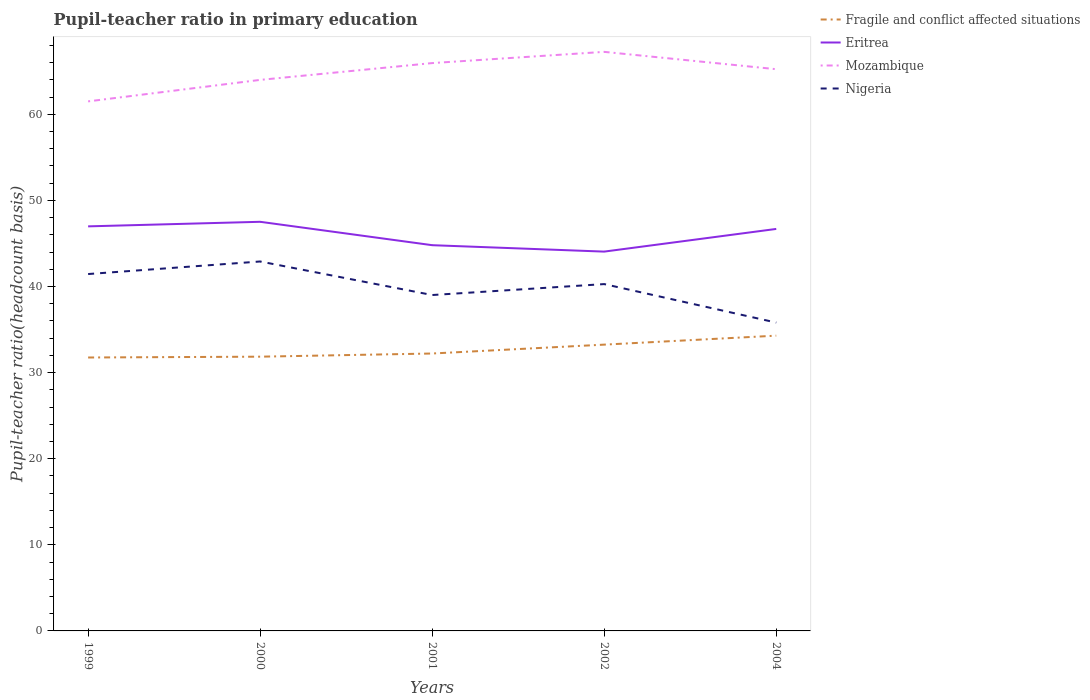Does the line corresponding to Mozambique intersect with the line corresponding to Nigeria?
Provide a succinct answer. No. Is the number of lines equal to the number of legend labels?
Keep it short and to the point. Yes. Across all years, what is the maximum pupil-teacher ratio in primary education in Fragile and conflict affected situations?
Offer a very short reply. 31.75. What is the total pupil-teacher ratio in primary education in Eritrea in the graph?
Offer a very short reply. 0.75. What is the difference between the highest and the second highest pupil-teacher ratio in primary education in Fragile and conflict affected situations?
Give a very brief answer. 2.54. How many lines are there?
Give a very brief answer. 4. How many years are there in the graph?
Provide a short and direct response. 5. Does the graph contain any zero values?
Provide a succinct answer. No. Where does the legend appear in the graph?
Provide a short and direct response. Top right. How are the legend labels stacked?
Make the answer very short. Vertical. What is the title of the graph?
Your answer should be compact. Pupil-teacher ratio in primary education. What is the label or title of the X-axis?
Your answer should be compact. Years. What is the label or title of the Y-axis?
Offer a very short reply. Pupil-teacher ratio(headcount basis). What is the Pupil-teacher ratio(headcount basis) of Fragile and conflict affected situations in 1999?
Offer a very short reply. 31.75. What is the Pupil-teacher ratio(headcount basis) of Eritrea in 1999?
Ensure brevity in your answer.  46.98. What is the Pupil-teacher ratio(headcount basis) of Mozambique in 1999?
Ensure brevity in your answer.  61.49. What is the Pupil-teacher ratio(headcount basis) in Nigeria in 1999?
Ensure brevity in your answer.  41.44. What is the Pupil-teacher ratio(headcount basis) in Fragile and conflict affected situations in 2000?
Give a very brief answer. 31.85. What is the Pupil-teacher ratio(headcount basis) of Eritrea in 2000?
Your answer should be compact. 47.51. What is the Pupil-teacher ratio(headcount basis) of Mozambique in 2000?
Ensure brevity in your answer.  63.99. What is the Pupil-teacher ratio(headcount basis) in Nigeria in 2000?
Keep it short and to the point. 42.9. What is the Pupil-teacher ratio(headcount basis) in Fragile and conflict affected situations in 2001?
Ensure brevity in your answer.  32.22. What is the Pupil-teacher ratio(headcount basis) of Eritrea in 2001?
Offer a terse response. 44.79. What is the Pupil-teacher ratio(headcount basis) of Mozambique in 2001?
Keep it short and to the point. 65.94. What is the Pupil-teacher ratio(headcount basis) of Nigeria in 2001?
Offer a very short reply. 39.01. What is the Pupil-teacher ratio(headcount basis) in Fragile and conflict affected situations in 2002?
Your answer should be very brief. 33.25. What is the Pupil-teacher ratio(headcount basis) of Eritrea in 2002?
Your answer should be compact. 44.05. What is the Pupil-teacher ratio(headcount basis) in Mozambique in 2002?
Give a very brief answer. 67.24. What is the Pupil-teacher ratio(headcount basis) in Nigeria in 2002?
Provide a short and direct response. 40.28. What is the Pupil-teacher ratio(headcount basis) in Fragile and conflict affected situations in 2004?
Ensure brevity in your answer.  34.29. What is the Pupil-teacher ratio(headcount basis) of Eritrea in 2004?
Give a very brief answer. 46.68. What is the Pupil-teacher ratio(headcount basis) of Mozambique in 2004?
Keep it short and to the point. 65.23. What is the Pupil-teacher ratio(headcount basis) of Nigeria in 2004?
Offer a terse response. 35.81. Across all years, what is the maximum Pupil-teacher ratio(headcount basis) of Fragile and conflict affected situations?
Provide a succinct answer. 34.29. Across all years, what is the maximum Pupil-teacher ratio(headcount basis) of Eritrea?
Your answer should be very brief. 47.51. Across all years, what is the maximum Pupil-teacher ratio(headcount basis) in Mozambique?
Your answer should be compact. 67.24. Across all years, what is the maximum Pupil-teacher ratio(headcount basis) in Nigeria?
Offer a very short reply. 42.9. Across all years, what is the minimum Pupil-teacher ratio(headcount basis) of Fragile and conflict affected situations?
Your answer should be very brief. 31.75. Across all years, what is the minimum Pupil-teacher ratio(headcount basis) in Eritrea?
Make the answer very short. 44.05. Across all years, what is the minimum Pupil-teacher ratio(headcount basis) in Mozambique?
Provide a short and direct response. 61.49. Across all years, what is the minimum Pupil-teacher ratio(headcount basis) of Nigeria?
Ensure brevity in your answer.  35.81. What is the total Pupil-teacher ratio(headcount basis) in Fragile and conflict affected situations in the graph?
Give a very brief answer. 163.35. What is the total Pupil-teacher ratio(headcount basis) of Eritrea in the graph?
Keep it short and to the point. 230.02. What is the total Pupil-teacher ratio(headcount basis) of Mozambique in the graph?
Provide a short and direct response. 323.9. What is the total Pupil-teacher ratio(headcount basis) in Nigeria in the graph?
Give a very brief answer. 199.43. What is the difference between the Pupil-teacher ratio(headcount basis) in Fragile and conflict affected situations in 1999 and that in 2000?
Provide a short and direct response. -0.1. What is the difference between the Pupil-teacher ratio(headcount basis) in Eritrea in 1999 and that in 2000?
Your response must be concise. -0.53. What is the difference between the Pupil-teacher ratio(headcount basis) of Mozambique in 1999 and that in 2000?
Give a very brief answer. -2.5. What is the difference between the Pupil-teacher ratio(headcount basis) of Nigeria in 1999 and that in 2000?
Give a very brief answer. -1.46. What is the difference between the Pupil-teacher ratio(headcount basis) of Fragile and conflict affected situations in 1999 and that in 2001?
Make the answer very short. -0.46. What is the difference between the Pupil-teacher ratio(headcount basis) of Eritrea in 1999 and that in 2001?
Offer a very short reply. 2.19. What is the difference between the Pupil-teacher ratio(headcount basis) in Mozambique in 1999 and that in 2001?
Offer a terse response. -4.45. What is the difference between the Pupil-teacher ratio(headcount basis) in Nigeria in 1999 and that in 2001?
Your response must be concise. 2.44. What is the difference between the Pupil-teacher ratio(headcount basis) of Fragile and conflict affected situations in 1999 and that in 2002?
Your answer should be compact. -1.49. What is the difference between the Pupil-teacher ratio(headcount basis) in Eritrea in 1999 and that in 2002?
Your answer should be compact. 2.93. What is the difference between the Pupil-teacher ratio(headcount basis) of Mozambique in 1999 and that in 2002?
Your response must be concise. -5.75. What is the difference between the Pupil-teacher ratio(headcount basis) of Nigeria in 1999 and that in 2002?
Offer a terse response. 1.17. What is the difference between the Pupil-teacher ratio(headcount basis) in Fragile and conflict affected situations in 1999 and that in 2004?
Provide a succinct answer. -2.54. What is the difference between the Pupil-teacher ratio(headcount basis) of Eritrea in 1999 and that in 2004?
Provide a short and direct response. 0.3. What is the difference between the Pupil-teacher ratio(headcount basis) in Mozambique in 1999 and that in 2004?
Your response must be concise. -3.74. What is the difference between the Pupil-teacher ratio(headcount basis) of Nigeria in 1999 and that in 2004?
Your response must be concise. 5.64. What is the difference between the Pupil-teacher ratio(headcount basis) in Fragile and conflict affected situations in 2000 and that in 2001?
Provide a succinct answer. -0.37. What is the difference between the Pupil-teacher ratio(headcount basis) in Eritrea in 2000 and that in 2001?
Give a very brief answer. 2.72. What is the difference between the Pupil-teacher ratio(headcount basis) of Mozambique in 2000 and that in 2001?
Your response must be concise. -1.95. What is the difference between the Pupil-teacher ratio(headcount basis) in Nigeria in 2000 and that in 2001?
Your answer should be very brief. 3.9. What is the difference between the Pupil-teacher ratio(headcount basis) in Fragile and conflict affected situations in 2000 and that in 2002?
Make the answer very short. -1.4. What is the difference between the Pupil-teacher ratio(headcount basis) of Eritrea in 2000 and that in 2002?
Ensure brevity in your answer.  3.46. What is the difference between the Pupil-teacher ratio(headcount basis) in Mozambique in 2000 and that in 2002?
Provide a short and direct response. -3.26. What is the difference between the Pupil-teacher ratio(headcount basis) of Nigeria in 2000 and that in 2002?
Make the answer very short. 2.62. What is the difference between the Pupil-teacher ratio(headcount basis) in Fragile and conflict affected situations in 2000 and that in 2004?
Your response must be concise. -2.44. What is the difference between the Pupil-teacher ratio(headcount basis) in Eritrea in 2000 and that in 2004?
Your response must be concise. 0.83. What is the difference between the Pupil-teacher ratio(headcount basis) of Mozambique in 2000 and that in 2004?
Give a very brief answer. -1.24. What is the difference between the Pupil-teacher ratio(headcount basis) in Nigeria in 2000 and that in 2004?
Provide a short and direct response. 7.09. What is the difference between the Pupil-teacher ratio(headcount basis) of Fragile and conflict affected situations in 2001 and that in 2002?
Provide a succinct answer. -1.03. What is the difference between the Pupil-teacher ratio(headcount basis) of Eritrea in 2001 and that in 2002?
Make the answer very short. 0.75. What is the difference between the Pupil-teacher ratio(headcount basis) of Mozambique in 2001 and that in 2002?
Your response must be concise. -1.3. What is the difference between the Pupil-teacher ratio(headcount basis) of Nigeria in 2001 and that in 2002?
Make the answer very short. -1.27. What is the difference between the Pupil-teacher ratio(headcount basis) of Fragile and conflict affected situations in 2001 and that in 2004?
Provide a succinct answer. -2.07. What is the difference between the Pupil-teacher ratio(headcount basis) in Eritrea in 2001 and that in 2004?
Give a very brief answer. -1.89. What is the difference between the Pupil-teacher ratio(headcount basis) of Mozambique in 2001 and that in 2004?
Ensure brevity in your answer.  0.71. What is the difference between the Pupil-teacher ratio(headcount basis) of Nigeria in 2001 and that in 2004?
Give a very brief answer. 3.2. What is the difference between the Pupil-teacher ratio(headcount basis) in Fragile and conflict affected situations in 2002 and that in 2004?
Ensure brevity in your answer.  -1.04. What is the difference between the Pupil-teacher ratio(headcount basis) of Eritrea in 2002 and that in 2004?
Your response must be concise. -2.63. What is the difference between the Pupil-teacher ratio(headcount basis) in Mozambique in 2002 and that in 2004?
Your answer should be very brief. 2.01. What is the difference between the Pupil-teacher ratio(headcount basis) in Nigeria in 2002 and that in 2004?
Your answer should be very brief. 4.47. What is the difference between the Pupil-teacher ratio(headcount basis) of Fragile and conflict affected situations in 1999 and the Pupil-teacher ratio(headcount basis) of Eritrea in 2000?
Provide a succinct answer. -15.76. What is the difference between the Pupil-teacher ratio(headcount basis) in Fragile and conflict affected situations in 1999 and the Pupil-teacher ratio(headcount basis) in Mozambique in 2000?
Keep it short and to the point. -32.24. What is the difference between the Pupil-teacher ratio(headcount basis) in Fragile and conflict affected situations in 1999 and the Pupil-teacher ratio(headcount basis) in Nigeria in 2000?
Offer a very short reply. -11.15. What is the difference between the Pupil-teacher ratio(headcount basis) in Eritrea in 1999 and the Pupil-teacher ratio(headcount basis) in Mozambique in 2000?
Make the answer very short. -17.01. What is the difference between the Pupil-teacher ratio(headcount basis) of Eritrea in 1999 and the Pupil-teacher ratio(headcount basis) of Nigeria in 2000?
Ensure brevity in your answer.  4.08. What is the difference between the Pupil-teacher ratio(headcount basis) in Mozambique in 1999 and the Pupil-teacher ratio(headcount basis) in Nigeria in 2000?
Ensure brevity in your answer.  18.59. What is the difference between the Pupil-teacher ratio(headcount basis) of Fragile and conflict affected situations in 1999 and the Pupil-teacher ratio(headcount basis) of Eritrea in 2001?
Provide a short and direct response. -13.04. What is the difference between the Pupil-teacher ratio(headcount basis) of Fragile and conflict affected situations in 1999 and the Pupil-teacher ratio(headcount basis) of Mozambique in 2001?
Your answer should be very brief. -34.19. What is the difference between the Pupil-teacher ratio(headcount basis) in Fragile and conflict affected situations in 1999 and the Pupil-teacher ratio(headcount basis) in Nigeria in 2001?
Provide a short and direct response. -7.25. What is the difference between the Pupil-teacher ratio(headcount basis) of Eritrea in 1999 and the Pupil-teacher ratio(headcount basis) of Mozambique in 2001?
Provide a succinct answer. -18.96. What is the difference between the Pupil-teacher ratio(headcount basis) in Eritrea in 1999 and the Pupil-teacher ratio(headcount basis) in Nigeria in 2001?
Offer a very short reply. 7.97. What is the difference between the Pupil-teacher ratio(headcount basis) in Mozambique in 1999 and the Pupil-teacher ratio(headcount basis) in Nigeria in 2001?
Offer a terse response. 22.49. What is the difference between the Pupil-teacher ratio(headcount basis) of Fragile and conflict affected situations in 1999 and the Pupil-teacher ratio(headcount basis) of Eritrea in 2002?
Provide a short and direct response. -12.3. What is the difference between the Pupil-teacher ratio(headcount basis) in Fragile and conflict affected situations in 1999 and the Pupil-teacher ratio(headcount basis) in Mozambique in 2002?
Your response must be concise. -35.49. What is the difference between the Pupil-teacher ratio(headcount basis) of Fragile and conflict affected situations in 1999 and the Pupil-teacher ratio(headcount basis) of Nigeria in 2002?
Offer a very short reply. -8.52. What is the difference between the Pupil-teacher ratio(headcount basis) of Eritrea in 1999 and the Pupil-teacher ratio(headcount basis) of Mozambique in 2002?
Provide a succinct answer. -20.26. What is the difference between the Pupil-teacher ratio(headcount basis) of Eritrea in 1999 and the Pupil-teacher ratio(headcount basis) of Nigeria in 2002?
Ensure brevity in your answer.  6.7. What is the difference between the Pupil-teacher ratio(headcount basis) in Mozambique in 1999 and the Pupil-teacher ratio(headcount basis) in Nigeria in 2002?
Offer a very short reply. 21.22. What is the difference between the Pupil-teacher ratio(headcount basis) of Fragile and conflict affected situations in 1999 and the Pupil-teacher ratio(headcount basis) of Eritrea in 2004?
Offer a very short reply. -14.93. What is the difference between the Pupil-teacher ratio(headcount basis) of Fragile and conflict affected situations in 1999 and the Pupil-teacher ratio(headcount basis) of Mozambique in 2004?
Your answer should be very brief. -33.48. What is the difference between the Pupil-teacher ratio(headcount basis) in Fragile and conflict affected situations in 1999 and the Pupil-teacher ratio(headcount basis) in Nigeria in 2004?
Ensure brevity in your answer.  -4.05. What is the difference between the Pupil-teacher ratio(headcount basis) in Eritrea in 1999 and the Pupil-teacher ratio(headcount basis) in Mozambique in 2004?
Your answer should be very brief. -18.25. What is the difference between the Pupil-teacher ratio(headcount basis) in Eritrea in 1999 and the Pupil-teacher ratio(headcount basis) in Nigeria in 2004?
Make the answer very short. 11.17. What is the difference between the Pupil-teacher ratio(headcount basis) of Mozambique in 1999 and the Pupil-teacher ratio(headcount basis) of Nigeria in 2004?
Provide a short and direct response. 25.69. What is the difference between the Pupil-teacher ratio(headcount basis) in Fragile and conflict affected situations in 2000 and the Pupil-teacher ratio(headcount basis) in Eritrea in 2001?
Provide a succinct answer. -12.95. What is the difference between the Pupil-teacher ratio(headcount basis) of Fragile and conflict affected situations in 2000 and the Pupil-teacher ratio(headcount basis) of Mozambique in 2001?
Give a very brief answer. -34.09. What is the difference between the Pupil-teacher ratio(headcount basis) of Fragile and conflict affected situations in 2000 and the Pupil-teacher ratio(headcount basis) of Nigeria in 2001?
Ensure brevity in your answer.  -7.16. What is the difference between the Pupil-teacher ratio(headcount basis) of Eritrea in 2000 and the Pupil-teacher ratio(headcount basis) of Mozambique in 2001?
Provide a succinct answer. -18.43. What is the difference between the Pupil-teacher ratio(headcount basis) of Eritrea in 2000 and the Pupil-teacher ratio(headcount basis) of Nigeria in 2001?
Give a very brief answer. 8.5. What is the difference between the Pupil-teacher ratio(headcount basis) of Mozambique in 2000 and the Pupil-teacher ratio(headcount basis) of Nigeria in 2001?
Ensure brevity in your answer.  24.98. What is the difference between the Pupil-teacher ratio(headcount basis) of Fragile and conflict affected situations in 2000 and the Pupil-teacher ratio(headcount basis) of Eritrea in 2002?
Ensure brevity in your answer.  -12.2. What is the difference between the Pupil-teacher ratio(headcount basis) in Fragile and conflict affected situations in 2000 and the Pupil-teacher ratio(headcount basis) in Mozambique in 2002?
Give a very brief answer. -35.4. What is the difference between the Pupil-teacher ratio(headcount basis) in Fragile and conflict affected situations in 2000 and the Pupil-teacher ratio(headcount basis) in Nigeria in 2002?
Your answer should be very brief. -8.43. What is the difference between the Pupil-teacher ratio(headcount basis) of Eritrea in 2000 and the Pupil-teacher ratio(headcount basis) of Mozambique in 2002?
Offer a very short reply. -19.73. What is the difference between the Pupil-teacher ratio(headcount basis) in Eritrea in 2000 and the Pupil-teacher ratio(headcount basis) in Nigeria in 2002?
Your answer should be very brief. 7.23. What is the difference between the Pupil-teacher ratio(headcount basis) of Mozambique in 2000 and the Pupil-teacher ratio(headcount basis) of Nigeria in 2002?
Provide a short and direct response. 23.71. What is the difference between the Pupil-teacher ratio(headcount basis) of Fragile and conflict affected situations in 2000 and the Pupil-teacher ratio(headcount basis) of Eritrea in 2004?
Your answer should be very brief. -14.83. What is the difference between the Pupil-teacher ratio(headcount basis) in Fragile and conflict affected situations in 2000 and the Pupil-teacher ratio(headcount basis) in Mozambique in 2004?
Ensure brevity in your answer.  -33.38. What is the difference between the Pupil-teacher ratio(headcount basis) of Fragile and conflict affected situations in 2000 and the Pupil-teacher ratio(headcount basis) of Nigeria in 2004?
Your answer should be very brief. -3.96. What is the difference between the Pupil-teacher ratio(headcount basis) in Eritrea in 2000 and the Pupil-teacher ratio(headcount basis) in Mozambique in 2004?
Give a very brief answer. -17.72. What is the difference between the Pupil-teacher ratio(headcount basis) in Eritrea in 2000 and the Pupil-teacher ratio(headcount basis) in Nigeria in 2004?
Make the answer very short. 11.7. What is the difference between the Pupil-teacher ratio(headcount basis) in Mozambique in 2000 and the Pupil-teacher ratio(headcount basis) in Nigeria in 2004?
Give a very brief answer. 28.18. What is the difference between the Pupil-teacher ratio(headcount basis) in Fragile and conflict affected situations in 2001 and the Pupil-teacher ratio(headcount basis) in Eritrea in 2002?
Give a very brief answer. -11.83. What is the difference between the Pupil-teacher ratio(headcount basis) in Fragile and conflict affected situations in 2001 and the Pupil-teacher ratio(headcount basis) in Mozambique in 2002?
Make the answer very short. -35.03. What is the difference between the Pupil-teacher ratio(headcount basis) in Fragile and conflict affected situations in 2001 and the Pupil-teacher ratio(headcount basis) in Nigeria in 2002?
Offer a very short reply. -8.06. What is the difference between the Pupil-teacher ratio(headcount basis) of Eritrea in 2001 and the Pupil-teacher ratio(headcount basis) of Mozambique in 2002?
Provide a succinct answer. -22.45. What is the difference between the Pupil-teacher ratio(headcount basis) in Eritrea in 2001 and the Pupil-teacher ratio(headcount basis) in Nigeria in 2002?
Offer a terse response. 4.52. What is the difference between the Pupil-teacher ratio(headcount basis) in Mozambique in 2001 and the Pupil-teacher ratio(headcount basis) in Nigeria in 2002?
Provide a short and direct response. 25.66. What is the difference between the Pupil-teacher ratio(headcount basis) of Fragile and conflict affected situations in 2001 and the Pupil-teacher ratio(headcount basis) of Eritrea in 2004?
Keep it short and to the point. -14.47. What is the difference between the Pupil-teacher ratio(headcount basis) in Fragile and conflict affected situations in 2001 and the Pupil-teacher ratio(headcount basis) in Mozambique in 2004?
Give a very brief answer. -33.02. What is the difference between the Pupil-teacher ratio(headcount basis) of Fragile and conflict affected situations in 2001 and the Pupil-teacher ratio(headcount basis) of Nigeria in 2004?
Your answer should be very brief. -3.59. What is the difference between the Pupil-teacher ratio(headcount basis) in Eritrea in 2001 and the Pupil-teacher ratio(headcount basis) in Mozambique in 2004?
Offer a terse response. -20.44. What is the difference between the Pupil-teacher ratio(headcount basis) of Eritrea in 2001 and the Pupil-teacher ratio(headcount basis) of Nigeria in 2004?
Your answer should be very brief. 8.99. What is the difference between the Pupil-teacher ratio(headcount basis) of Mozambique in 2001 and the Pupil-teacher ratio(headcount basis) of Nigeria in 2004?
Give a very brief answer. 30.13. What is the difference between the Pupil-teacher ratio(headcount basis) of Fragile and conflict affected situations in 2002 and the Pupil-teacher ratio(headcount basis) of Eritrea in 2004?
Your response must be concise. -13.44. What is the difference between the Pupil-teacher ratio(headcount basis) of Fragile and conflict affected situations in 2002 and the Pupil-teacher ratio(headcount basis) of Mozambique in 2004?
Your answer should be compact. -31.98. What is the difference between the Pupil-teacher ratio(headcount basis) of Fragile and conflict affected situations in 2002 and the Pupil-teacher ratio(headcount basis) of Nigeria in 2004?
Make the answer very short. -2.56. What is the difference between the Pupil-teacher ratio(headcount basis) in Eritrea in 2002 and the Pupil-teacher ratio(headcount basis) in Mozambique in 2004?
Offer a terse response. -21.18. What is the difference between the Pupil-teacher ratio(headcount basis) in Eritrea in 2002 and the Pupil-teacher ratio(headcount basis) in Nigeria in 2004?
Offer a terse response. 8.24. What is the difference between the Pupil-teacher ratio(headcount basis) of Mozambique in 2002 and the Pupil-teacher ratio(headcount basis) of Nigeria in 2004?
Keep it short and to the point. 31.44. What is the average Pupil-teacher ratio(headcount basis) of Fragile and conflict affected situations per year?
Keep it short and to the point. 32.67. What is the average Pupil-teacher ratio(headcount basis) in Eritrea per year?
Offer a very short reply. 46. What is the average Pupil-teacher ratio(headcount basis) of Mozambique per year?
Provide a short and direct response. 64.78. What is the average Pupil-teacher ratio(headcount basis) of Nigeria per year?
Provide a short and direct response. 39.89. In the year 1999, what is the difference between the Pupil-teacher ratio(headcount basis) of Fragile and conflict affected situations and Pupil-teacher ratio(headcount basis) of Eritrea?
Offer a very short reply. -15.23. In the year 1999, what is the difference between the Pupil-teacher ratio(headcount basis) of Fragile and conflict affected situations and Pupil-teacher ratio(headcount basis) of Mozambique?
Your response must be concise. -29.74. In the year 1999, what is the difference between the Pupil-teacher ratio(headcount basis) of Fragile and conflict affected situations and Pupil-teacher ratio(headcount basis) of Nigeria?
Your answer should be compact. -9.69. In the year 1999, what is the difference between the Pupil-teacher ratio(headcount basis) in Eritrea and Pupil-teacher ratio(headcount basis) in Mozambique?
Provide a short and direct response. -14.51. In the year 1999, what is the difference between the Pupil-teacher ratio(headcount basis) of Eritrea and Pupil-teacher ratio(headcount basis) of Nigeria?
Offer a terse response. 5.54. In the year 1999, what is the difference between the Pupil-teacher ratio(headcount basis) in Mozambique and Pupil-teacher ratio(headcount basis) in Nigeria?
Your answer should be compact. 20.05. In the year 2000, what is the difference between the Pupil-teacher ratio(headcount basis) of Fragile and conflict affected situations and Pupil-teacher ratio(headcount basis) of Eritrea?
Provide a succinct answer. -15.66. In the year 2000, what is the difference between the Pupil-teacher ratio(headcount basis) of Fragile and conflict affected situations and Pupil-teacher ratio(headcount basis) of Mozambique?
Keep it short and to the point. -32.14. In the year 2000, what is the difference between the Pupil-teacher ratio(headcount basis) of Fragile and conflict affected situations and Pupil-teacher ratio(headcount basis) of Nigeria?
Provide a short and direct response. -11.05. In the year 2000, what is the difference between the Pupil-teacher ratio(headcount basis) of Eritrea and Pupil-teacher ratio(headcount basis) of Mozambique?
Offer a terse response. -16.48. In the year 2000, what is the difference between the Pupil-teacher ratio(headcount basis) of Eritrea and Pupil-teacher ratio(headcount basis) of Nigeria?
Provide a short and direct response. 4.61. In the year 2000, what is the difference between the Pupil-teacher ratio(headcount basis) of Mozambique and Pupil-teacher ratio(headcount basis) of Nigeria?
Provide a short and direct response. 21.09. In the year 2001, what is the difference between the Pupil-teacher ratio(headcount basis) in Fragile and conflict affected situations and Pupil-teacher ratio(headcount basis) in Eritrea?
Offer a very short reply. -12.58. In the year 2001, what is the difference between the Pupil-teacher ratio(headcount basis) of Fragile and conflict affected situations and Pupil-teacher ratio(headcount basis) of Mozambique?
Offer a very short reply. -33.73. In the year 2001, what is the difference between the Pupil-teacher ratio(headcount basis) in Fragile and conflict affected situations and Pupil-teacher ratio(headcount basis) in Nigeria?
Ensure brevity in your answer.  -6.79. In the year 2001, what is the difference between the Pupil-teacher ratio(headcount basis) of Eritrea and Pupil-teacher ratio(headcount basis) of Mozambique?
Offer a terse response. -21.15. In the year 2001, what is the difference between the Pupil-teacher ratio(headcount basis) of Eritrea and Pupil-teacher ratio(headcount basis) of Nigeria?
Your answer should be compact. 5.79. In the year 2001, what is the difference between the Pupil-teacher ratio(headcount basis) in Mozambique and Pupil-teacher ratio(headcount basis) in Nigeria?
Your answer should be very brief. 26.94. In the year 2002, what is the difference between the Pupil-teacher ratio(headcount basis) of Fragile and conflict affected situations and Pupil-teacher ratio(headcount basis) of Eritrea?
Your answer should be very brief. -10.8. In the year 2002, what is the difference between the Pupil-teacher ratio(headcount basis) of Fragile and conflict affected situations and Pupil-teacher ratio(headcount basis) of Mozambique?
Your answer should be compact. -34. In the year 2002, what is the difference between the Pupil-teacher ratio(headcount basis) of Fragile and conflict affected situations and Pupil-teacher ratio(headcount basis) of Nigeria?
Provide a succinct answer. -7.03. In the year 2002, what is the difference between the Pupil-teacher ratio(headcount basis) in Eritrea and Pupil-teacher ratio(headcount basis) in Mozambique?
Give a very brief answer. -23.2. In the year 2002, what is the difference between the Pupil-teacher ratio(headcount basis) in Eritrea and Pupil-teacher ratio(headcount basis) in Nigeria?
Make the answer very short. 3.77. In the year 2002, what is the difference between the Pupil-teacher ratio(headcount basis) of Mozambique and Pupil-teacher ratio(headcount basis) of Nigeria?
Offer a terse response. 26.97. In the year 2004, what is the difference between the Pupil-teacher ratio(headcount basis) in Fragile and conflict affected situations and Pupil-teacher ratio(headcount basis) in Eritrea?
Offer a terse response. -12.39. In the year 2004, what is the difference between the Pupil-teacher ratio(headcount basis) of Fragile and conflict affected situations and Pupil-teacher ratio(headcount basis) of Mozambique?
Your response must be concise. -30.94. In the year 2004, what is the difference between the Pupil-teacher ratio(headcount basis) of Fragile and conflict affected situations and Pupil-teacher ratio(headcount basis) of Nigeria?
Give a very brief answer. -1.52. In the year 2004, what is the difference between the Pupil-teacher ratio(headcount basis) in Eritrea and Pupil-teacher ratio(headcount basis) in Mozambique?
Make the answer very short. -18.55. In the year 2004, what is the difference between the Pupil-teacher ratio(headcount basis) in Eritrea and Pupil-teacher ratio(headcount basis) in Nigeria?
Your answer should be compact. 10.88. In the year 2004, what is the difference between the Pupil-teacher ratio(headcount basis) in Mozambique and Pupil-teacher ratio(headcount basis) in Nigeria?
Your answer should be compact. 29.42. What is the ratio of the Pupil-teacher ratio(headcount basis) in Fragile and conflict affected situations in 1999 to that in 2000?
Provide a succinct answer. 1. What is the ratio of the Pupil-teacher ratio(headcount basis) in Eritrea in 1999 to that in 2000?
Your answer should be very brief. 0.99. What is the ratio of the Pupil-teacher ratio(headcount basis) of Mozambique in 1999 to that in 2000?
Offer a very short reply. 0.96. What is the ratio of the Pupil-teacher ratio(headcount basis) in Nigeria in 1999 to that in 2000?
Give a very brief answer. 0.97. What is the ratio of the Pupil-teacher ratio(headcount basis) of Fragile and conflict affected situations in 1999 to that in 2001?
Offer a very short reply. 0.99. What is the ratio of the Pupil-teacher ratio(headcount basis) in Eritrea in 1999 to that in 2001?
Offer a terse response. 1.05. What is the ratio of the Pupil-teacher ratio(headcount basis) in Mozambique in 1999 to that in 2001?
Provide a succinct answer. 0.93. What is the ratio of the Pupil-teacher ratio(headcount basis) in Nigeria in 1999 to that in 2001?
Offer a terse response. 1.06. What is the ratio of the Pupil-teacher ratio(headcount basis) of Fragile and conflict affected situations in 1999 to that in 2002?
Your response must be concise. 0.96. What is the ratio of the Pupil-teacher ratio(headcount basis) in Eritrea in 1999 to that in 2002?
Offer a very short reply. 1.07. What is the ratio of the Pupil-teacher ratio(headcount basis) in Mozambique in 1999 to that in 2002?
Your answer should be very brief. 0.91. What is the ratio of the Pupil-teacher ratio(headcount basis) in Nigeria in 1999 to that in 2002?
Your answer should be compact. 1.03. What is the ratio of the Pupil-teacher ratio(headcount basis) of Fragile and conflict affected situations in 1999 to that in 2004?
Your answer should be compact. 0.93. What is the ratio of the Pupil-teacher ratio(headcount basis) of Eritrea in 1999 to that in 2004?
Offer a very short reply. 1.01. What is the ratio of the Pupil-teacher ratio(headcount basis) in Mozambique in 1999 to that in 2004?
Provide a succinct answer. 0.94. What is the ratio of the Pupil-teacher ratio(headcount basis) of Nigeria in 1999 to that in 2004?
Make the answer very short. 1.16. What is the ratio of the Pupil-teacher ratio(headcount basis) of Eritrea in 2000 to that in 2001?
Your answer should be very brief. 1.06. What is the ratio of the Pupil-teacher ratio(headcount basis) in Mozambique in 2000 to that in 2001?
Ensure brevity in your answer.  0.97. What is the ratio of the Pupil-teacher ratio(headcount basis) in Nigeria in 2000 to that in 2001?
Offer a very short reply. 1.1. What is the ratio of the Pupil-teacher ratio(headcount basis) of Fragile and conflict affected situations in 2000 to that in 2002?
Make the answer very short. 0.96. What is the ratio of the Pupil-teacher ratio(headcount basis) of Eritrea in 2000 to that in 2002?
Give a very brief answer. 1.08. What is the ratio of the Pupil-teacher ratio(headcount basis) in Mozambique in 2000 to that in 2002?
Your response must be concise. 0.95. What is the ratio of the Pupil-teacher ratio(headcount basis) of Nigeria in 2000 to that in 2002?
Offer a terse response. 1.07. What is the ratio of the Pupil-teacher ratio(headcount basis) in Fragile and conflict affected situations in 2000 to that in 2004?
Give a very brief answer. 0.93. What is the ratio of the Pupil-teacher ratio(headcount basis) in Eritrea in 2000 to that in 2004?
Offer a very short reply. 1.02. What is the ratio of the Pupil-teacher ratio(headcount basis) in Nigeria in 2000 to that in 2004?
Make the answer very short. 1.2. What is the ratio of the Pupil-teacher ratio(headcount basis) in Fragile and conflict affected situations in 2001 to that in 2002?
Your response must be concise. 0.97. What is the ratio of the Pupil-teacher ratio(headcount basis) in Eritrea in 2001 to that in 2002?
Give a very brief answer. 1.02. What is the ratio of the Pupil-teacher ratio(headcount basis) in Mozambique in 2001 to that in 2002?
Your answer should be very brief. 0.98. What is the ratio of the Pupil-teacher ratio(headcount basis) of Nigeria in 2001 to that in 2002?
Make the answer very short. 0.97. What is the ratio of the Pupil-teacher ratio(headcount basis) in Fragile and conflict affected situations in 2001 to that in 2004?
Offer a very short reply. 0.94. What is the ratio of the Pupil-teacher ratio(headcount basis) of Eritrea in 2001 to that in 2004?
Keep it short and to the point. 0.96. What is the ratio of the Pupil-teacher ratio(headcount basis) in Mozambique in 2001 to that in 2004?
Your answer should be compact. 1.01. What is the ratio of the Pupil-teacher ratio(headcount basis) of Nigeria in 2001 to that in 2004?
Provide a short and direct response. 1.09. What is the ratio of the Pupil-teacher ratio(headcount basis) of Fragile and conflict affected situations in 2002 to that in 2004?
Your answer should be compact. 0.97. What is the ratio of the Pupil-teacher ratio(headcount basis) in Eritrea in 2002 to that in 2004?
Offer a very short reply. 0.94. What is the ratio of the Pupil-teacher ratio(headcount basis) in Mozambique in 2002 to that in 2004?
Your answer should be compact. 1.03. What is the ratio of the Pupil-teacher ratio(headcount basis) in Nigeria in 2002 to that in 2004?
Give a very brief answer. 1.12. What is the difference between the highest and the second highest Pupil-teacher ratio(headcount basis) in Fragile and conflict affected situations?
Give a very brief answer. 1.04. What is the difference between the highest and the second highest Pupil-teacher ratio(headcount basis) in Eritrea?
Your answer should be very brief. 0.53. What is the difference between the highest and the second highest Pupil-teacher ratio(headcount basis) of Mozambique?
Give a very brief answer. 1.3. What is the difference between the highest and the second highest Pupil-teacher ratio(headcount basis) of Nigeria?
Your answer should be compact. 1.46. What is the difference between the highest and the lowest Pupil-teacher ratio(headcount basis) in Fragile and conflict affected situations?
Offer a very short reply. 2.54. What is the difference between the highest and the lowest Pupil-teacher ratio(headcount basis) of Eritrea?
Give a very brief answer. 3.46. What is the difference between the highest and the lowest Pupil-teacher ratio(headcount basis) of Mozambique?
Offer a terse response. 5.75. What is the difference between the highest and the lowest Pupil-teacher ratio(headcount basis) in Nigeria?
Your answer should be compact. 7.09. 